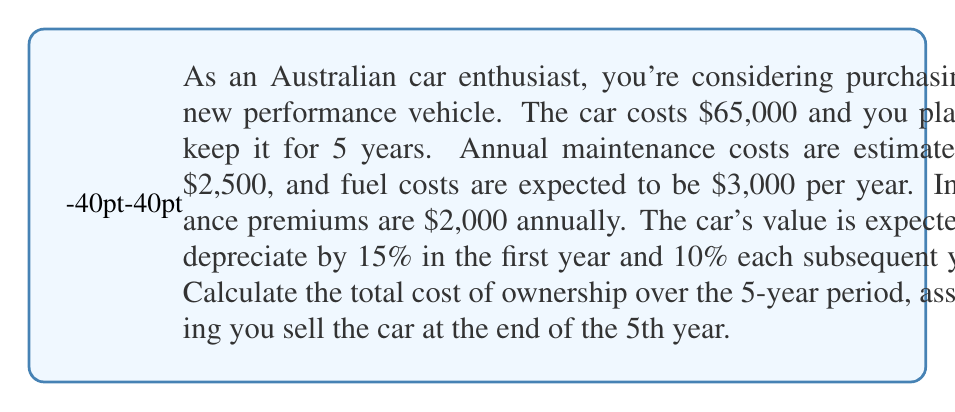Show me your answer to this math problem. Let's break this down step-by-step:

1. Initial cost: $65,000

2. Annual costs:
   - Maintenance: $2,500
   - Fuel: $3,000
   - Insurance: $2,000
   Total annual cost: $2,500 + $3,000 + $2,000 = $7,500

3. Depreciation calculation:
   - Year 1: $65,000 * (1 - 0.15) = $55,250
   - Year 2: $55,250 * (1 - 0.10) = $49,725
   - Year 3: $49,725 * (1 - 0.10) = $44,752.50
   - Year 4: $44,752.50 * (1 - 0.10) = $40,277.25
   - Year 5: $40,277.25 * (1 - 0.10) = $36,249.53

4. Total cost calculation:
   $$ \text{Total Cost} = \text{Initial Cost} + (5 * \text{Annual Costs}) - \text{Resale Value} $$
   $$ \text{Total Cost} = $65,000 + (5 * $7,500) - $36,249.53 $$
   $$ \text{Total Cost} = $65,000 + $37,500 - $36,249.53 $$
   $$ \text{Total Cost} = $66,250.47 $$
Answer: The total cost of ownership over the 5-year period is $66,250.47. 